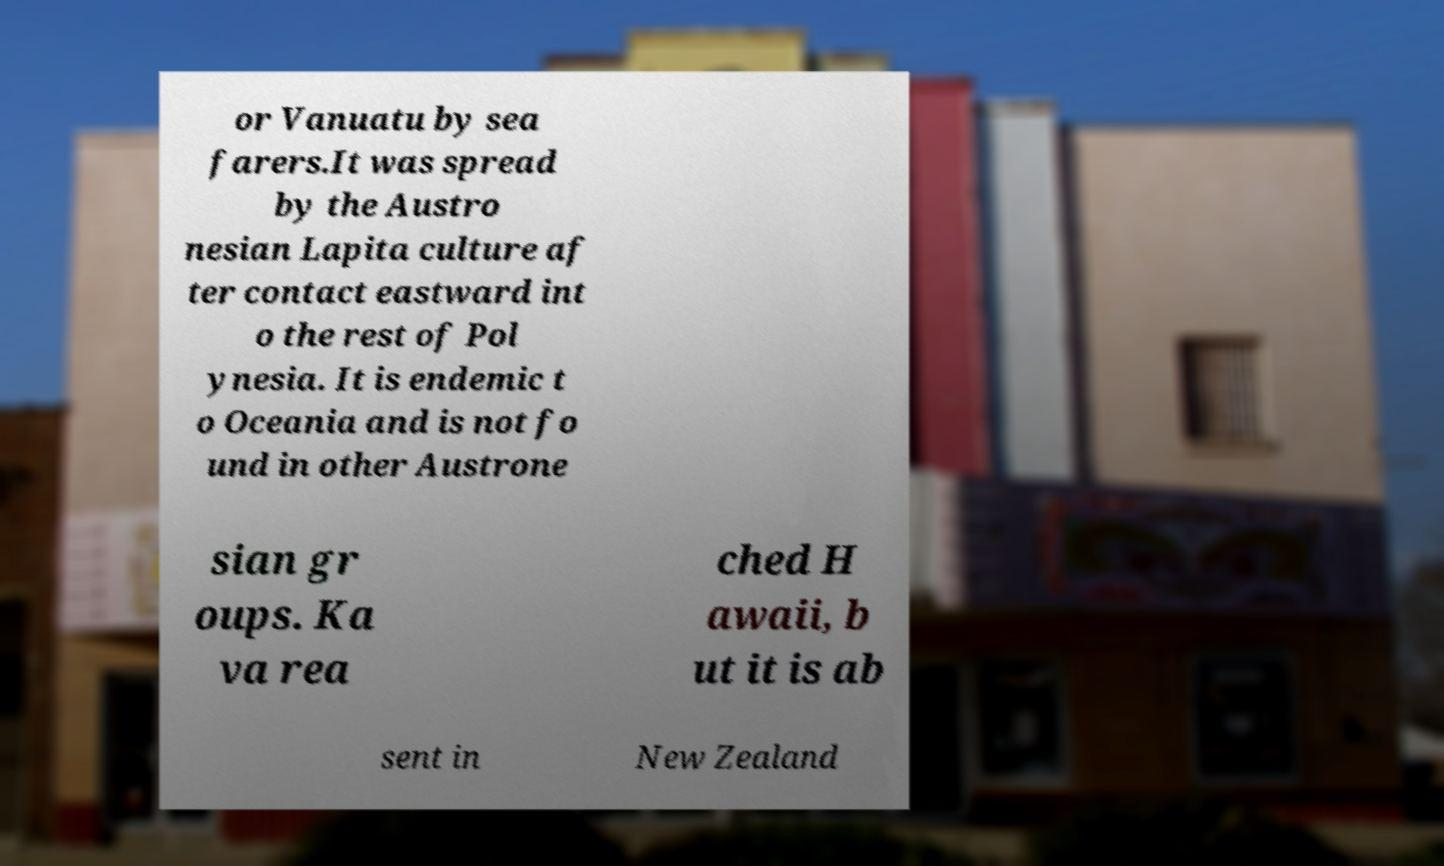What messages or text are displayed in this image? I need them in a readable, typed format. or Vanuatu by sea farers.It was spread by the Austro nesian Lapita culture af ter contact eastward int o the rest of Pol ynesia. It is endemic t o Oceania and is not fo und in other Austrone sian gr oups. Ka va rea ched H awaii, b ut it is ab sent in New Zealand 